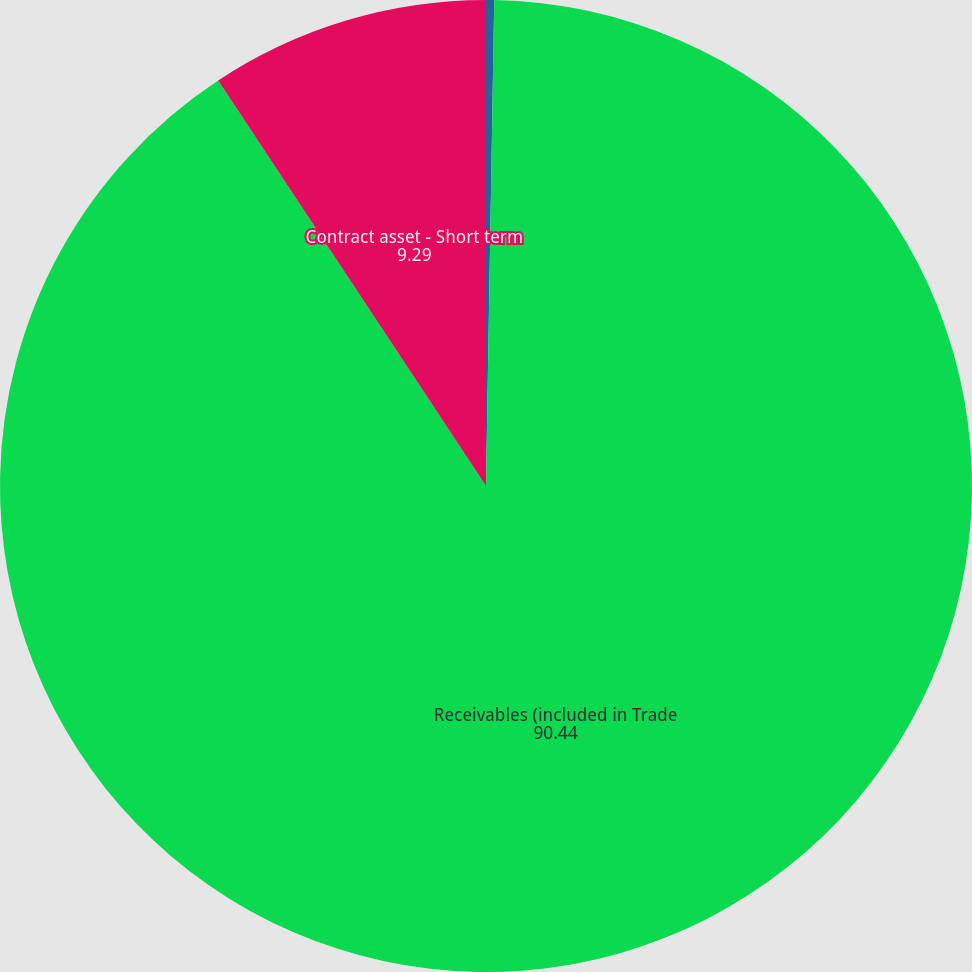Convert chart to OTSL. <chart><loc_0><loc_0><loc_500><loc_500><pie_chart><fcel>(DOLLARS IN THOUSANDS)<fcel>Receivables (included in Trade<fcel>Contract asset - Short term<nl><fcel>0.27%<fcel>90.44%<fcel>9.29%<nl></chart> 